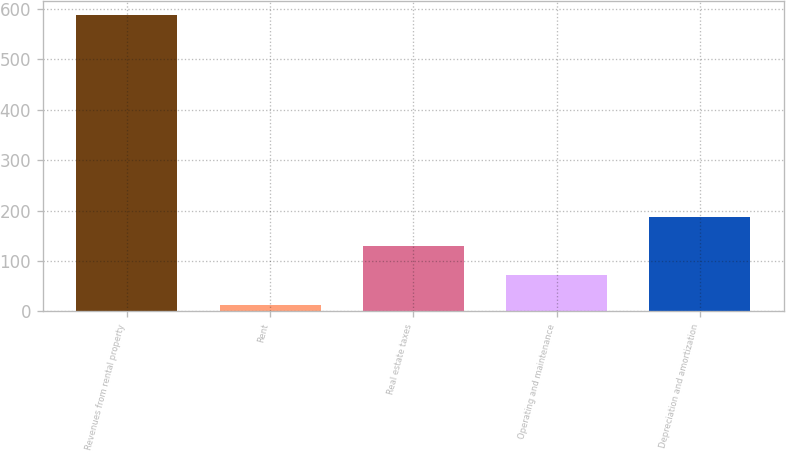<chart> <loc_0><loc_0><loc_500><loc_500><bar_chart><fcel>Revenues from rental property<fcel>Rent<fcel>Real estate taxes<fcel>Operating and maintenance<fcel>Depreciation and amortization<nl><fcel>587.5<fcel>11.5<fcel>130.3<fcel>72.7<fcel>187.9<nl></chart> 